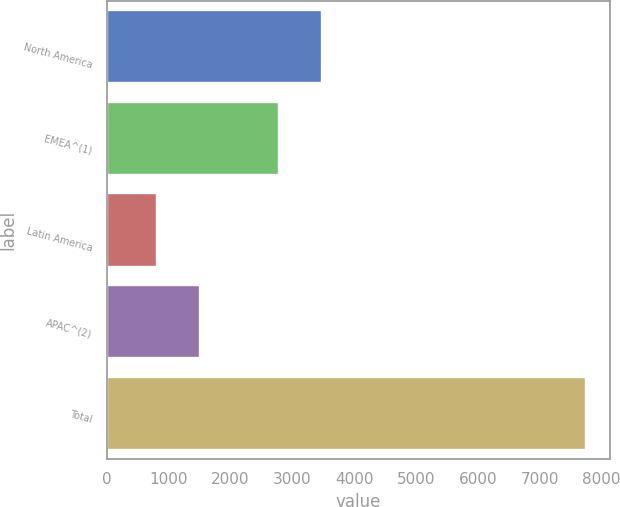<chart> <loc_0><loc_0><loc_500><loc_500><bar_chart><fcel>North America<fcel>EMEA^(1)<fcel>Latin America<fcel>APAC^(2)<fcel>Total<nl><fcel>3477.5<fcel>2783.2<fcel>807.5<fcel>1501.8<fcel>7750.5<nl></chart> 